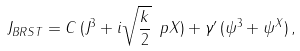Convert formula to latex. <formula><loc_0><loc_0><loc_500><loc_500>J _ { B R S T } & = C \, ( J ^ { 3 } + i \sqrt { \frac { k } { 2 } } \, \ p X ) + \gamma ^ { \prime } \, ( \psi ^ { 3 } + \psi ^ { X } ) \, ,</formula> 